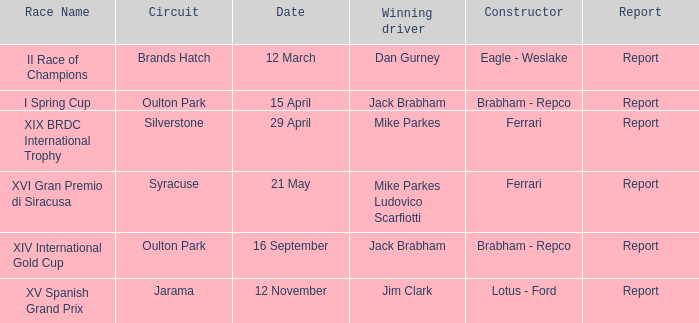What date was the xiv international gold cup? 16 September. 